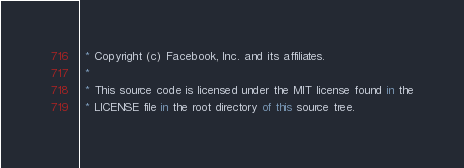Convert code to text. <code><loc_0><loc_0><loc_500><loc_500><_JavaScript_> * Copyright (c) Facebook, Inc. and its affiliates.
 *
 * This source code is licensed under the MIT license found in the
 * LICENSE file in the root directory of this source tree.</code> 